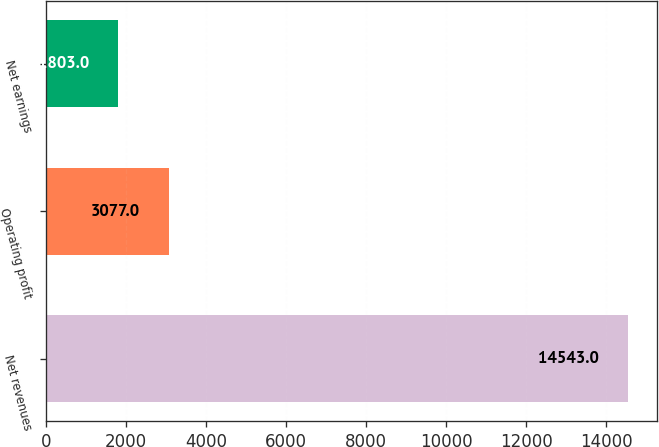Convert chart. <chart><loc_0><loc_0><loc_500><loc_500><bar_chart><fcel>Net revenues<fcel>Operating profit<fcel>Net earnings<nl><fcel>14543<fcel>3077<fcel>1803<nl></chart> 